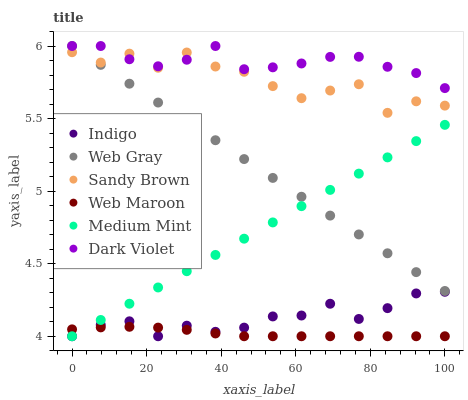Does Web Maroon have the minimum area under the curve?
Answer yes or no. Yes. Does Dark Violet have the maximum area under the curve?
Answer yes or no. Yes. Does Web Gray have the minimum area under the curve?
Answer yes or no. No. Does Web Gray have the maximum area under the curve?
Answer yes or no. No. Is Web Gray the smoothest?
Answer yes or no. Yes. Is Sandy Brown the roughest?
Answer yes or no. Yes. Is Indigo the smoothest?
Answer yes or no. No. Is Indigo the roughest?
Answer yes or no. No. Does Medium Mint have the lowest value?
Answer yes or no. Yes. Does Web Gray have the lowest value?
Answer yes or no. No. Does Dark Violet have the highest value?
Answer yes or no. Yes. Does Indigo have the highest value?
Answer yes or no. No. Is Web Maroon less than Sandy Brown?
Answer yes or no. Yes. Is Sandy Brown greater than Indigo?
Answer yes or no. Yes. Does Web Maroon intersect Indigo?
Answer yes or no. Yes. Is Web Maroon less than Indigo?
Answer yes or no. No. Is Web Maroon greater than Indigo?
Answer yes or no. No. Does Web Maroon intersect Sandy Brown?
Answer yes or no. No. 